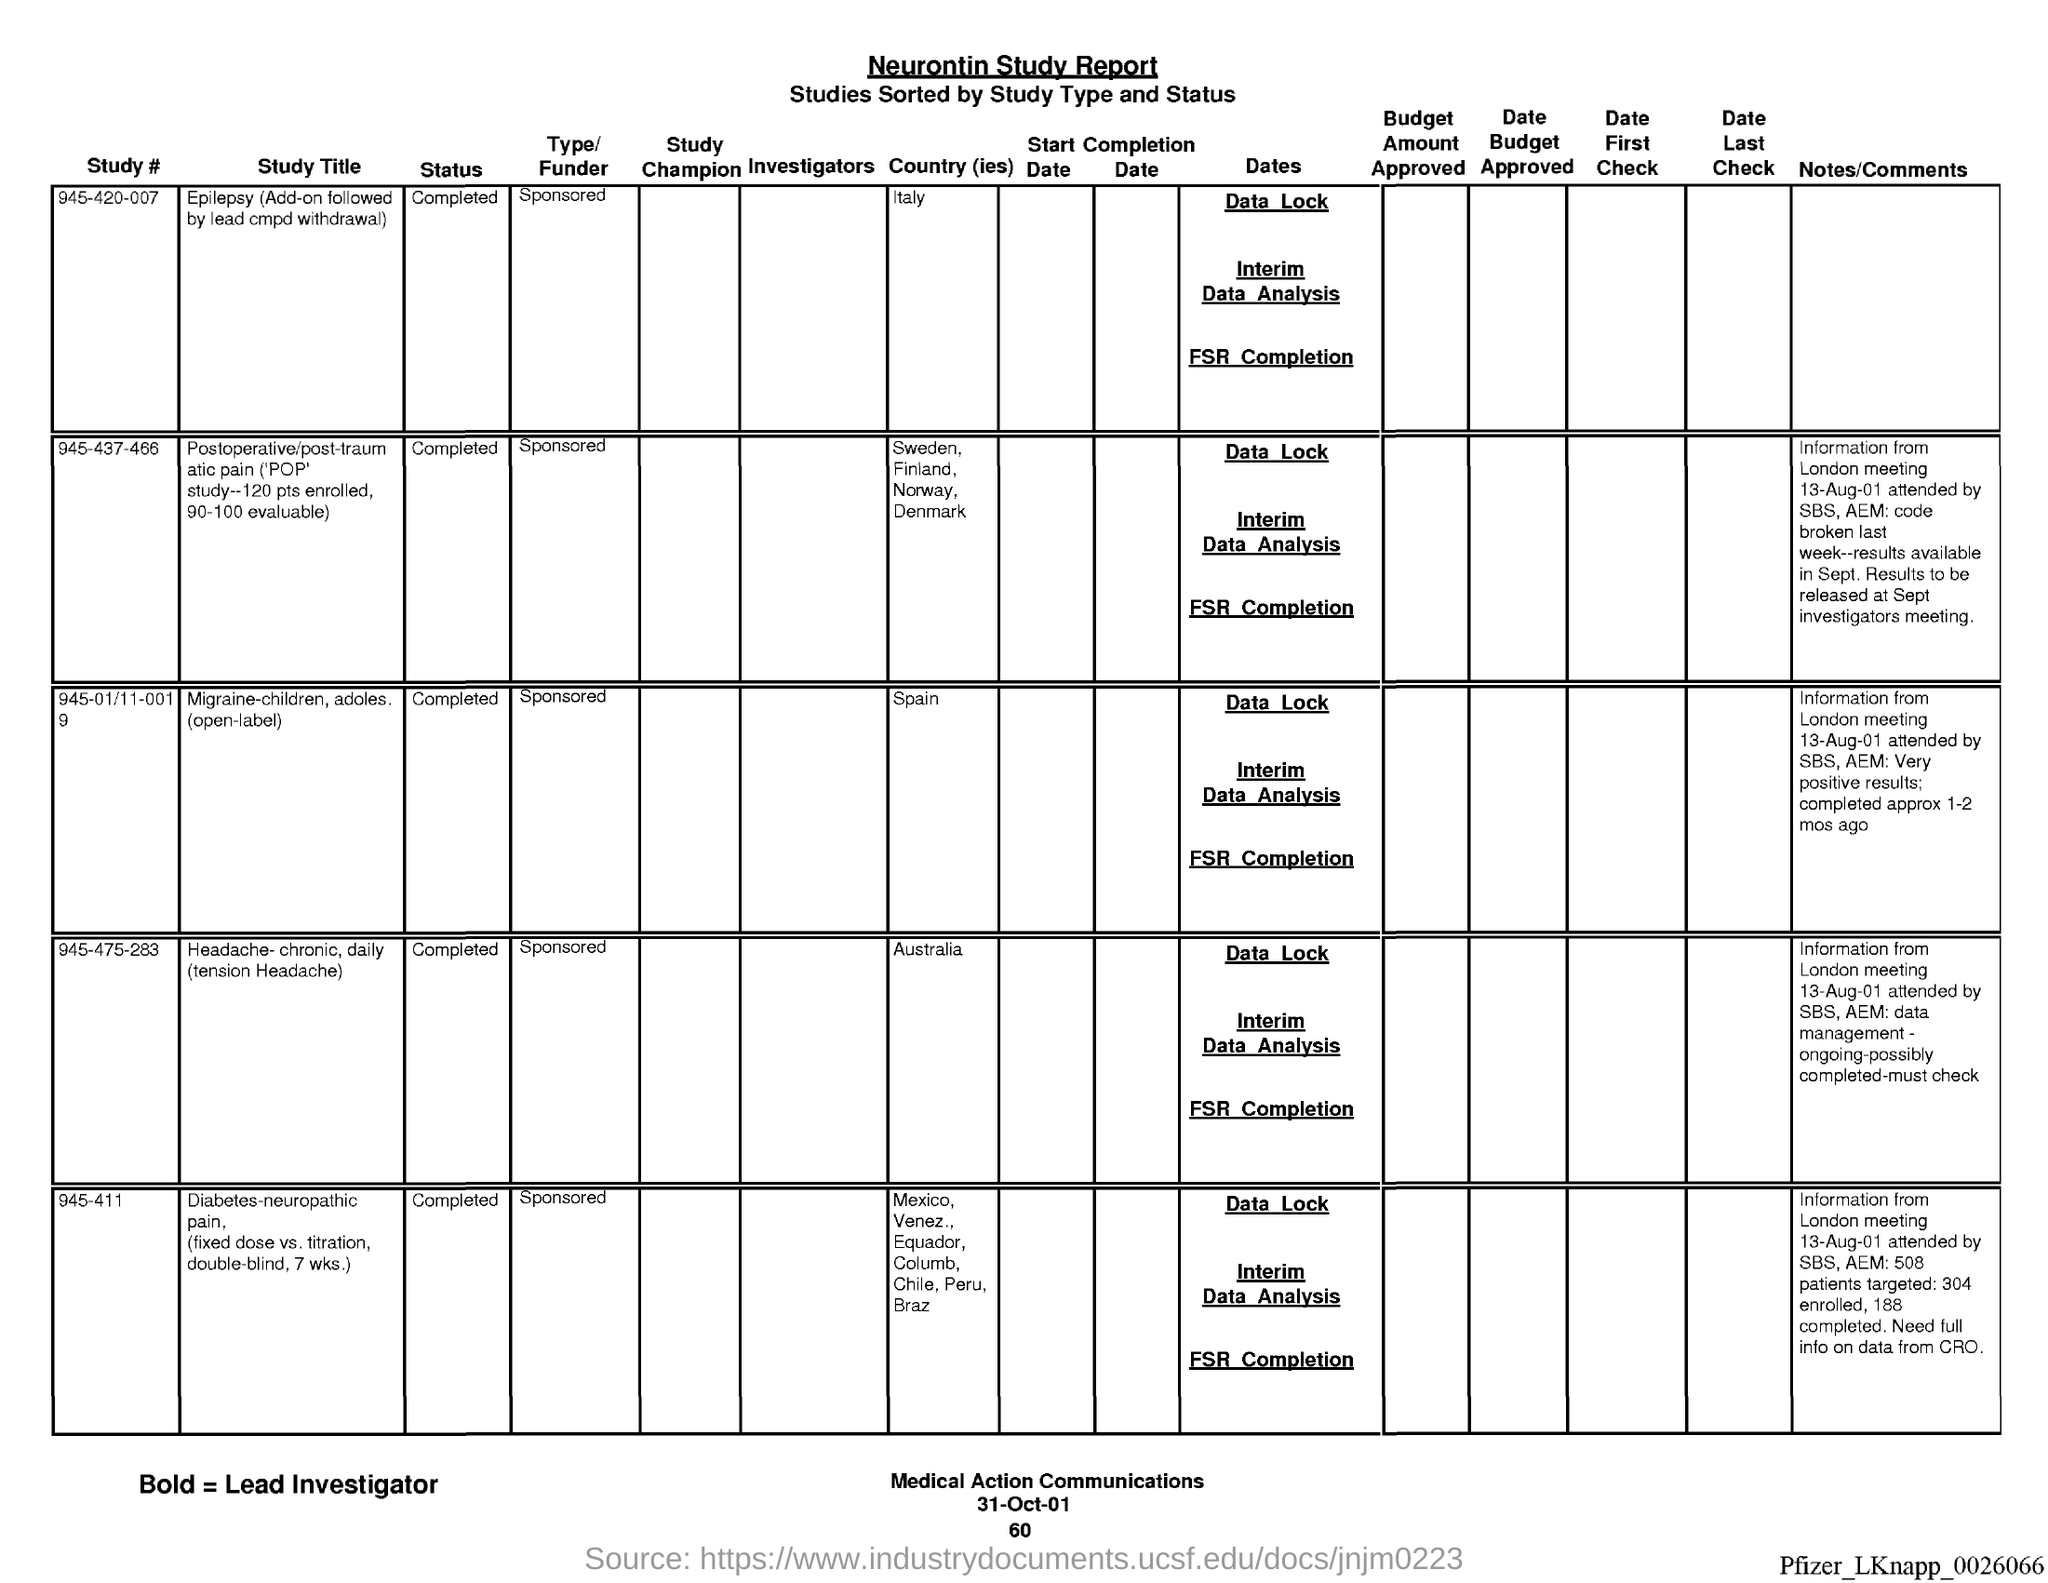What is the Title of the document?
Offer a terse response. Neurontin Study Report. What is the status for study #945-420-007?
Keep it short and to the point. Completed. What is the status for study #945-01/11-0019?
Provide a succinct answer. Completed. What is the status for study #945-475-283?
Offer a terse response. Completed. What is the status for study #945-411?
Provide a succinct answer. Completed. What is the country for study #945-420-007?
Your response must be concise. Italy. What is the country for study #945-01/11-0019?
Your response must be concise. Spain. What is country for study #945-475-283?
Ensure brevity in your answer.  Australia. What is the date on the document?
Offer a terse response. 31-Oct-01. 